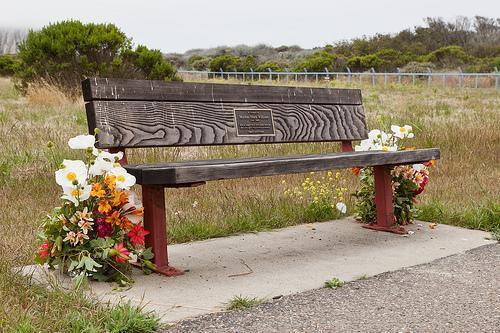How many flower arrangements?
Give a very brief answer. 2. 